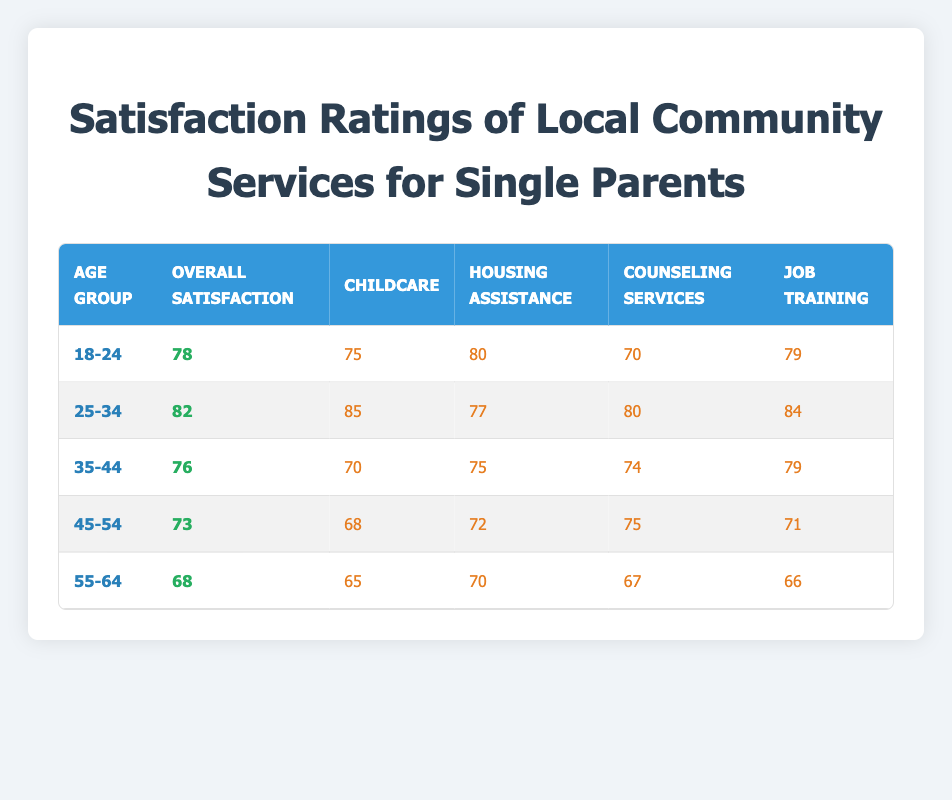What is the overall satisfaction score for single parents aged 35-44? The table shows that the overall satisfaction score for single parents in the age group 35-44 is listed in the corresponding row under the "Overall Satisfaction" column. That score is 76.
Answer: 76 Which age group has the highest satisfaction score for housing assistance? By examining the "Housing Assistance" column for each age group, the highest satisfaction score is 80 for the 18-24 age group.
Answer: 80 What is the average satisfaction score for all services provided to single parents aged 25-34? First, sum the service scores for the 25-34 age group: Childcare (85) + Housing Assistance (77) + Counseling Services (80) + Job Training (84) = 326. Then, divide by the number of services (4): 326/4 = 81.5.
Answer: 81.5 Is the satisfaction score for counseling services lower than the overall satisfaction score for single parents aged 45-54? The overall satisfaction score for this age group is 73, while the counseling services score is 75. Thus, the counseling services score is higher than the overall satisfaction score for the 45-54 age group.
Answer: No Which service received the lowest satisfaction score for single parents aged 55-64? The "Services" column for the 55-64 age group lists all service scores, and the lowest is Childcare at 65.
Answer: 65 What is the difference in satisfaction scores for job training services between the age groups 18-24 and 45-54? The job training score for the 18-24 age group is 79 and for the 45-54 age group is 71. The difference is calculated as 79 - 71 = 8.
Answer: 8 What is the satisfaction score for childcare for single parents aged 25-34 compared to those aged 35-44? The satisfaction score for childcare for the 25-34 age group is 85, while for the 35-44 age group, it is 70. Thus, childcare satisfaction for 25-34 is greater, as 85 > 70.
Answer: Yes Which age group has the lowest overall satisfaction score? By comparing the overall satisfaction scores for each age group, the 55-64 age group has the lowest score, which is 68.
Answer: 68 